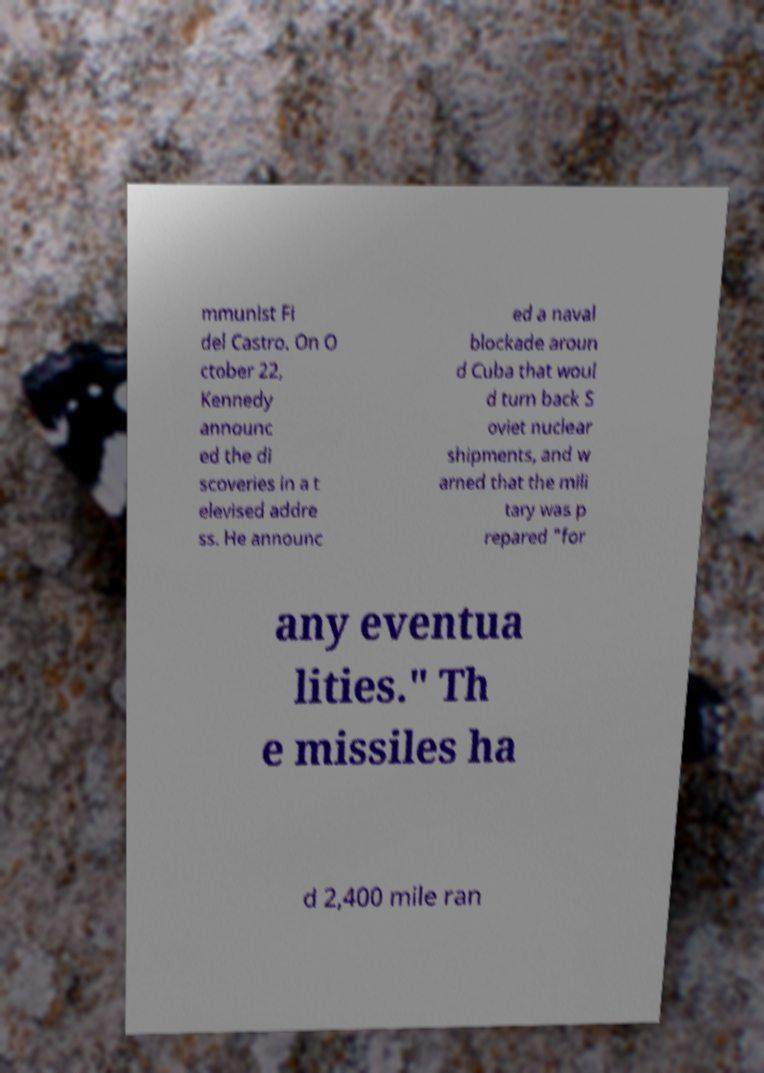Please identify and transcribe the text found in this image. mmunist Fi del Castro. On O ctober 22, Kennedy announc ed the di scoveries in a t elevised addre ss. He announc ed a naval blockade aroun d Cuba that woul d turn back S oviet nuclear shipments, and w arned that the mili tary was p repared "for any eventua lities." Th e missiles ha d 2,400 mile ran 